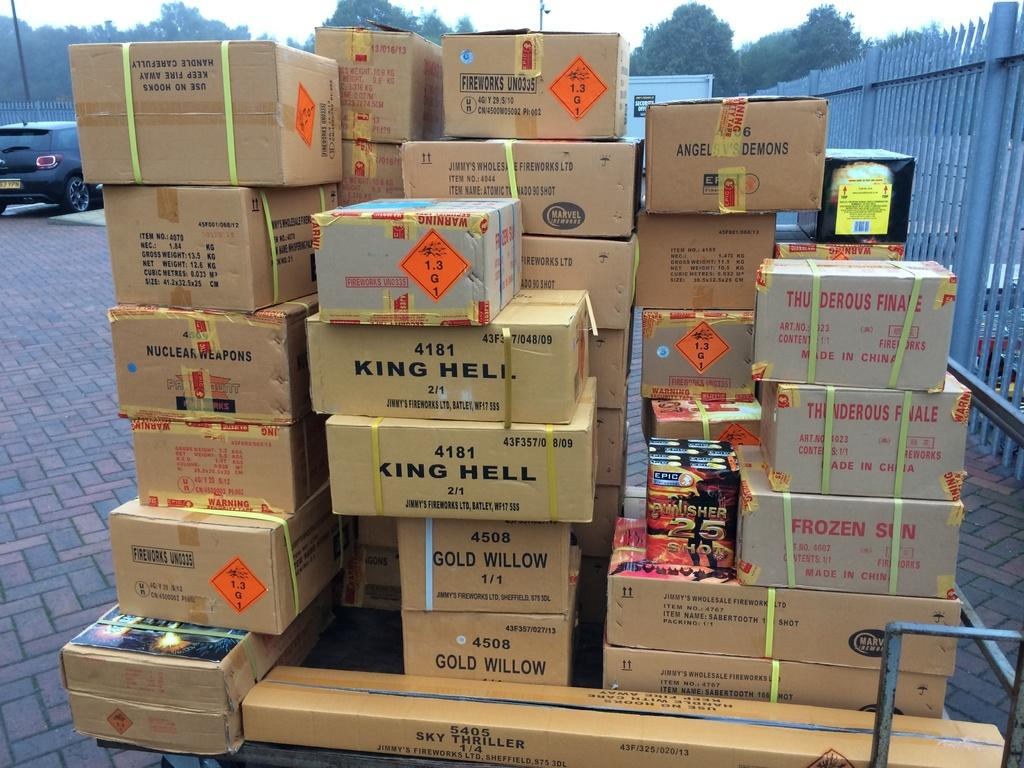<image>
Share a concise interpretation of the image provided. A stack of cardboard boxes includes two that say King Hell on them. 